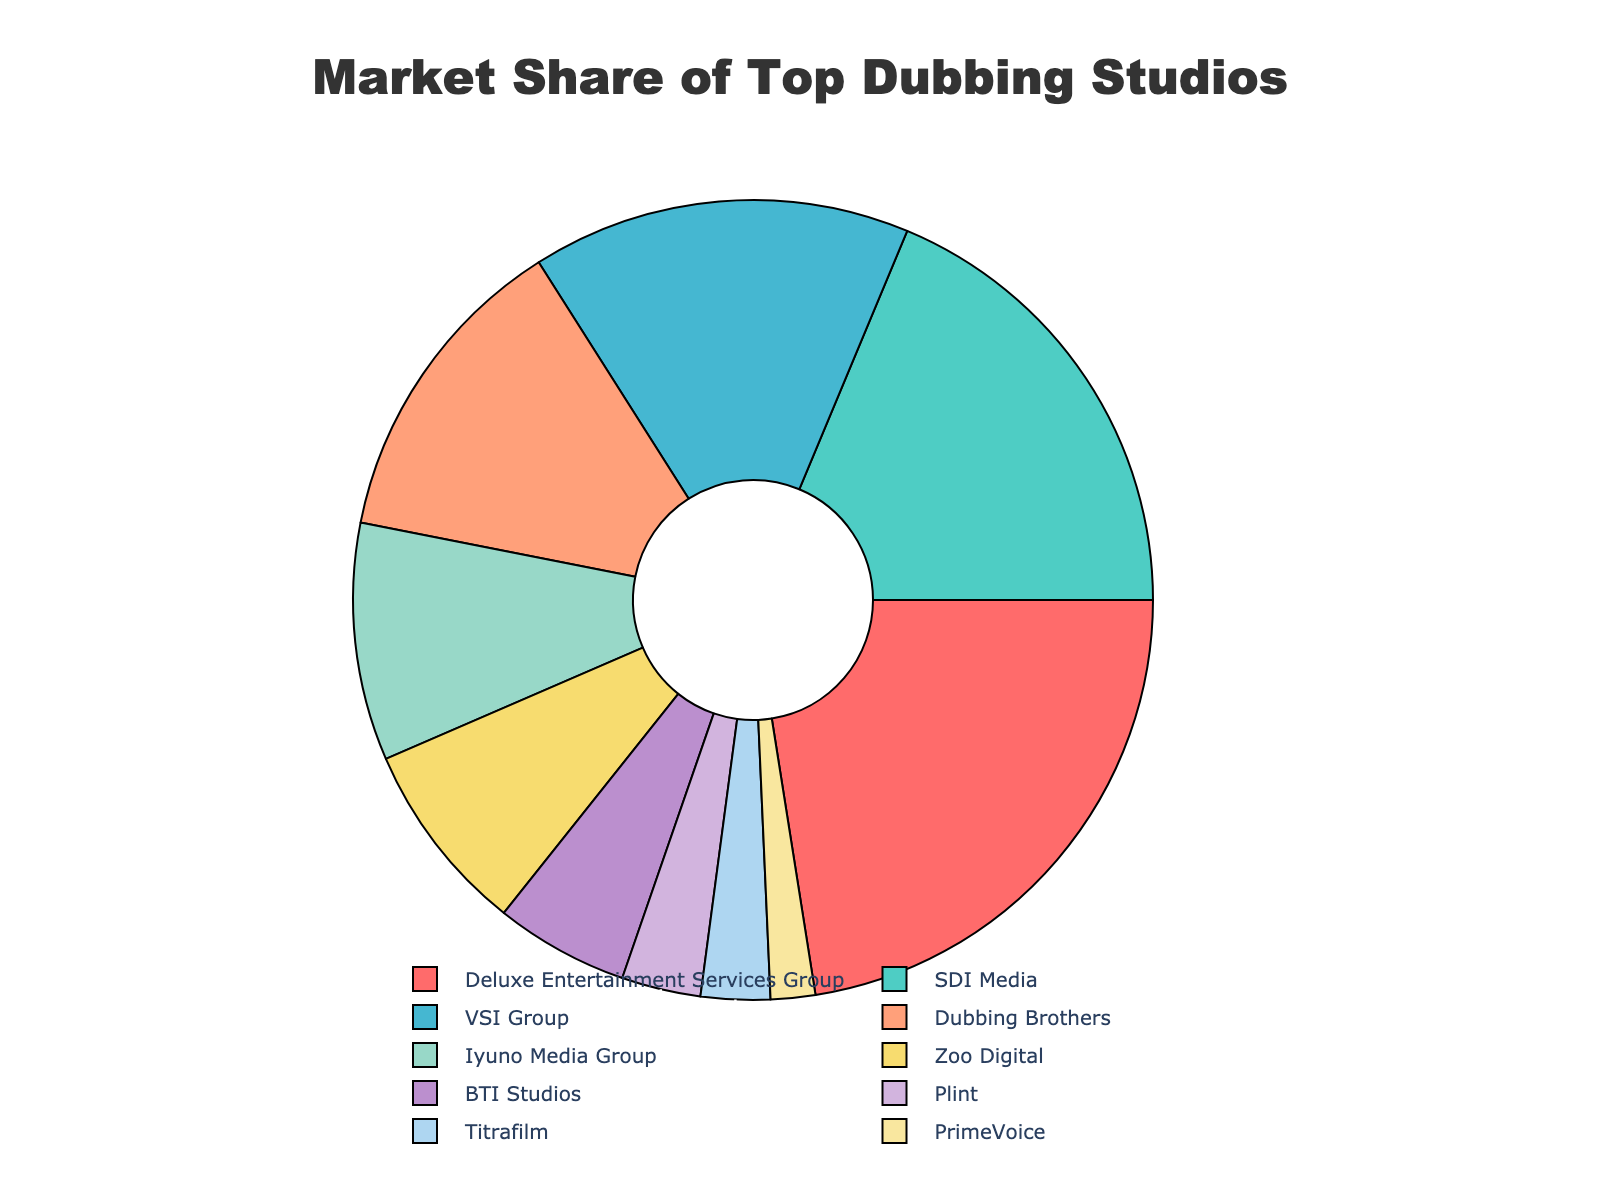Which studio has the largest market share? By looking at the pie chart, the segment with the largest area will indicate the studio with the largest market share.
Answer: Deluxe Entertainment Services Group What is the combined market share of the top three studios? Sum the market shares of the top three studios: Deluxe Entertainment Services Group (22.5%), SDI Media (18.7%), and VSI Group (15.3%). 22.5 + 18.7 + 15.3 = 56.5
Answer: 56.5 Which studio has a larger market share, Dubbing Brothers or Iyuno Media Group, and by how much? Compare the market shares of Dubbing Brothers (12.9%) and Iyuno Media Group (9.6%). Subtract the smaller share from the larger share: 12.9 - 9.6 = 3.3
Answer: Dubbing Brothers by 3.3 What is the total market share of studios with less than 5% share each? Add the market shares of studios with less than 5%: BTI Studios (5.4% is over 5%), Plint (3.2%), Titrafilm (2.8%), PrimeVoice (1.8%). 3.2 + 2.8 + 1.8 = 7.8
Answer: 7.8 What is the difference in market share between the studio with the smallest share and the studio with the largest share? Identify the market shares of the smallest and largest studios: PrimeVoice (1.8%) and Deluxe Entertainment Services Group (22.5%). Subtract the smallest from the largest: 22.5 - 1.8 = 20.7
Answer: 20.7 Which studio has a market share closest to 10%? Observe the market shares: Iyuno Media Group has a share of 9.6%, which is closest to 10%.
Answer: Iyuno Media Group What percentage of the market is held by studios other than the top three? Sum the market shares of all studios and subtract the combined share of the top three from it: Total market share from top three is 22.5 + 18.7 + 15.3 = 56.5. Subtract from 100%: 100 - 56.5 = 43.5
Answer: 43.5 What is the market share difference between Zoo Digital and BTI Studios? Subtract the market share of BTI Studios (5.4%) from Zoo Digital (7.8%): 7.8 - 5.4 = 2.4
Answer: 2.4 How many studios together own around 50% market share? Check the combined market share starting from the top: Deluxe Entertainment Services Group (22.5%) + SDI Media (18.7%) + VSI Group (15.3%) adds up to 56.5%, while just Deluxe Entertainment Services Group and SDI Media are together 22.5 + 18.7 = 41.2%, still below 50%. Thus, including VSI Group gives us the required 50%. The count is 3.
Answer: 3 